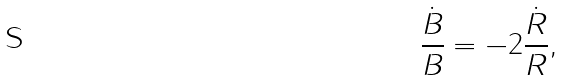<formula> <loc_0><loc_0><loc_500><loc_500>\frac { \dot { B } } { B } = - 2 \frac { \dot { R } } { R } ,</formula> 